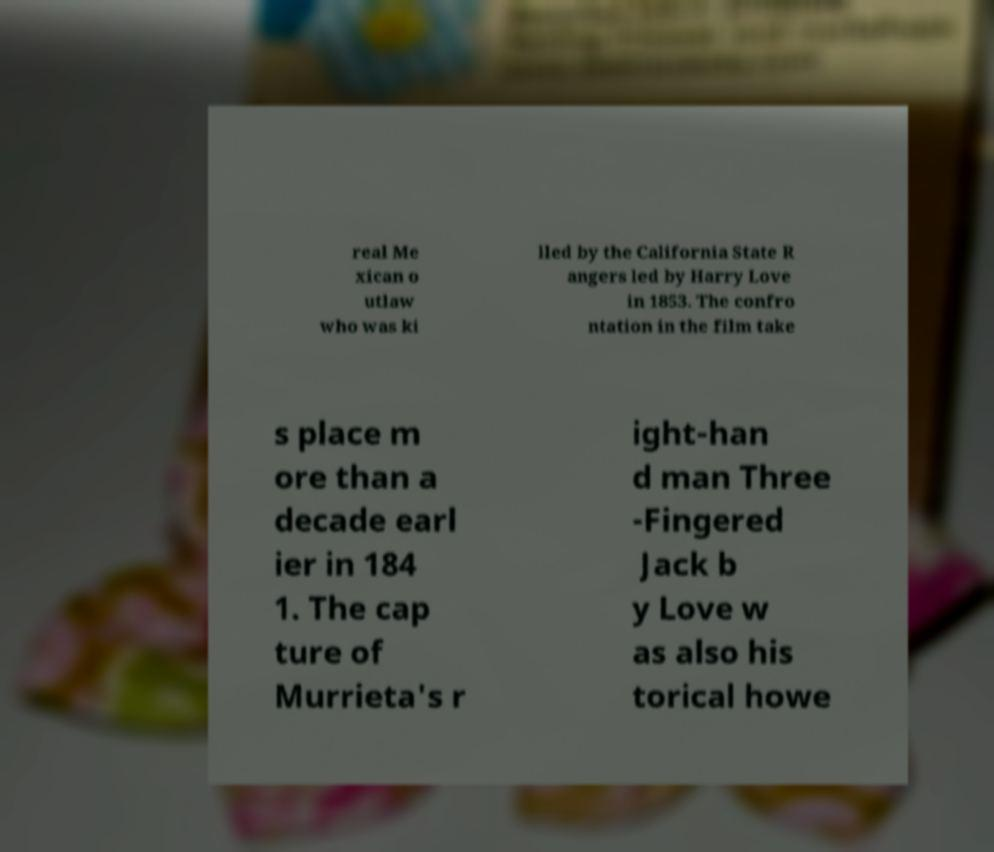Could you assist in decoding the text presented in this image and type it out clearly? real Me xican o utlaw who was ki lled by the California State R angers led by Harry Love in 1853. The confro ntation in the film take s place m ore than a decade earl ier in 184 1. The cap ture of Murrieta's r ight-han d man Three -Fingered Jack b y Love w as also his torical howe 